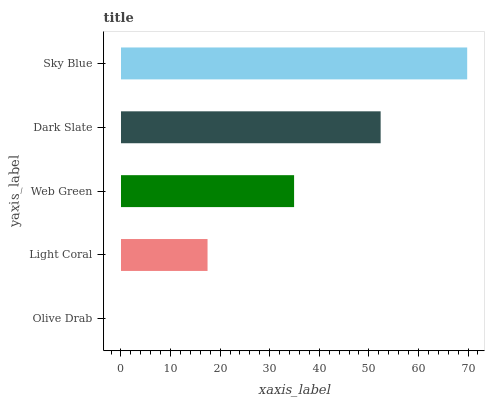Is Olive Drab the minimum?
Answer yes or no. Yes. Is Sky Blue the maximum?
Answer yes or no. Yes. Is Light Coral the minimum?
Answer yes or no. No. Is Light Coral the maximum?
Answer yes or no. No. Is Light Coral greater than Olive Drab?
Answer yes or no. Yes. Is Olive Drab less than Light Coral?
Answer yes or no. Yes. Is Olive Drab greater than Light Coral?
Answer yes or no. No. Is Light Coral less than Olive Drab?
Answer yes or no. No. Is Web Green the high median?
Answer yes or no. Yes. Is Web Green the low median?
Answer yes or no. Yes. Is Olive Drab the high median?
Answer yes or no. No. Is Sky Blue the low median?
Answer yes or no. No. 